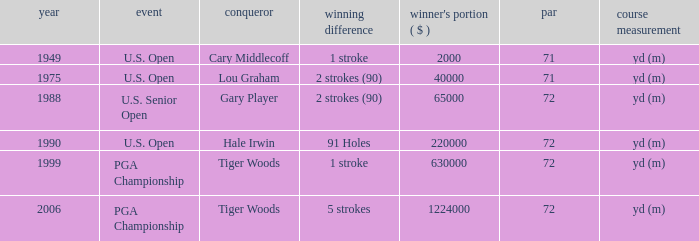When gary player is the winner what is the lowest winners share in dollars? 65000.0. 